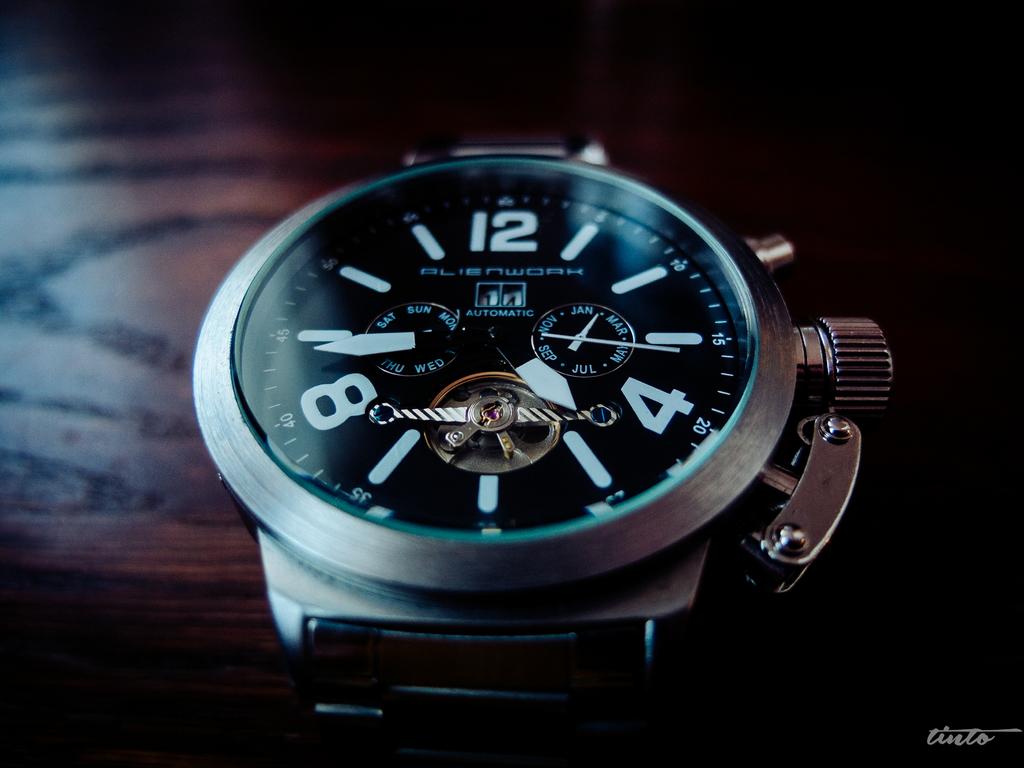What three numbers are shown?
Give a very brief answer. 12, 4, 8. 